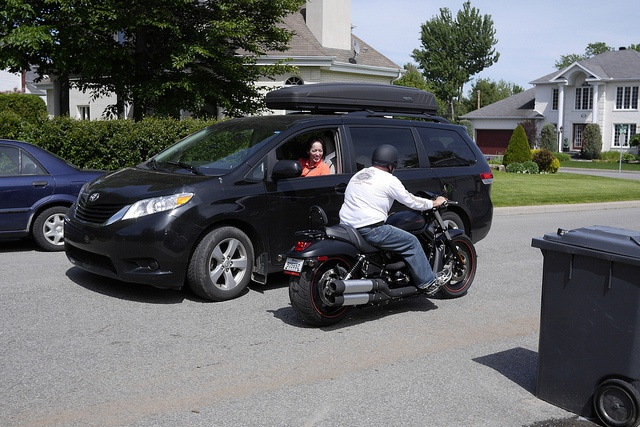Describe the objects in this image and their specific colors. I can see car in black, gray, and darkgray tones, motorcycle in black, gray, and darkgray tones, car in black, gray, and navy tones, people in black, white, and gray tones, and people in black, salmon, and maroon tones in this image. 